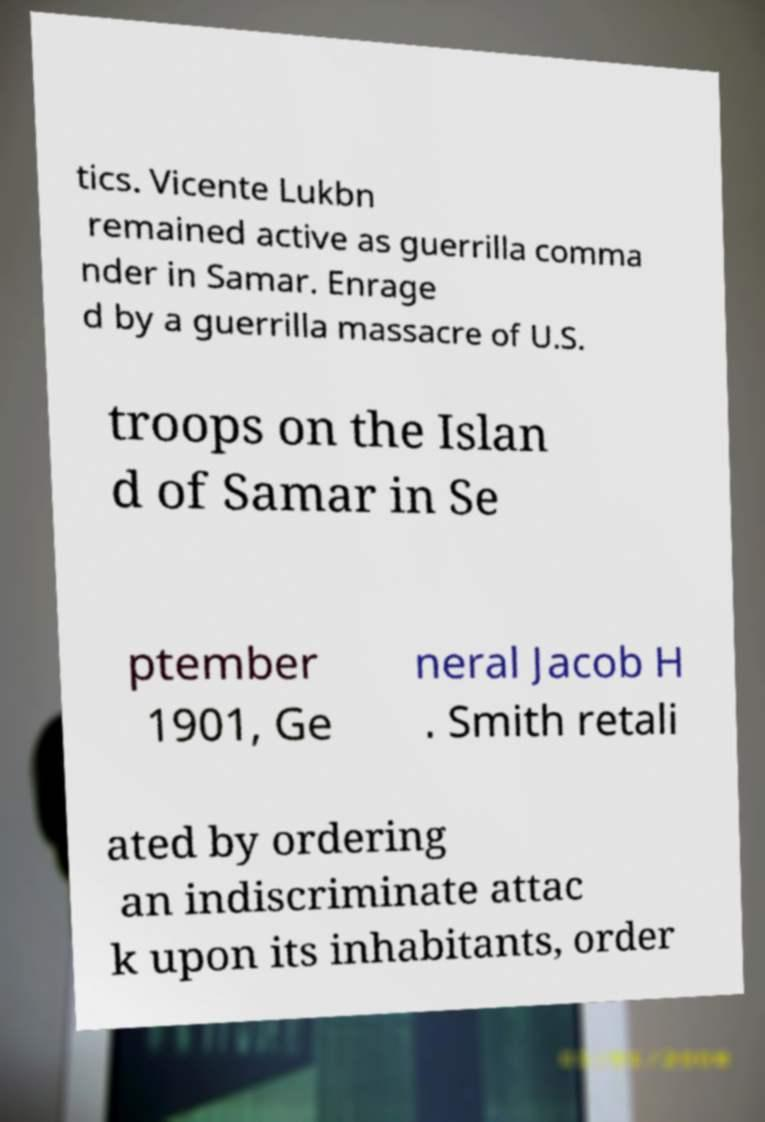Can you read and provide the text displayed in the image?This photo seems to have some interesting text. Can you extract and type it out for me? tics. Vicente Lukbn remained active as guerrilla comma nder in Samar. Enrage d by a guerrilla massacre of U.S. troops on the Islan d of Samar in Se ptember 1901, Ge neral Jacob H . Smith retali ated by ordering an indiscriminate attac k upon its inhabitants, order 